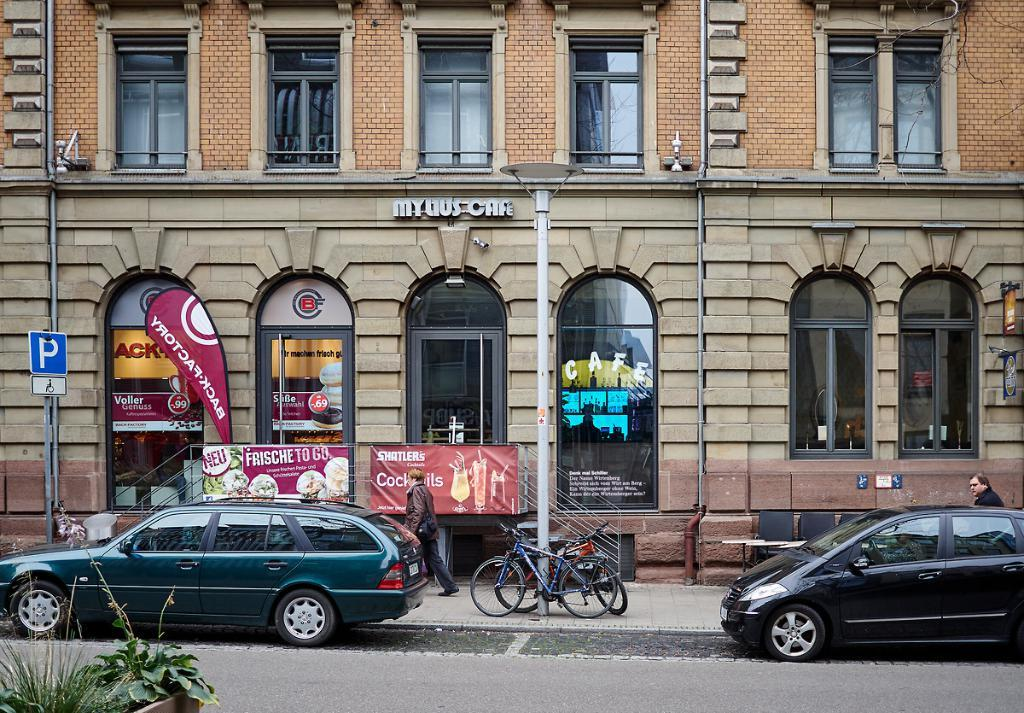How many vehicles can be seen in the image? There are two cars in the image. What other mode of transportation is present in the image? There are some bicycles in the image. Can you describe the person in the image? There is a person walking in the image. What type of structure is visible in the image? There is a building in the image. Where is the goose swimming in the image? There is no goose present in the image. Can you describe the jellyfish floating in the image? There are no jellyfish present in the image. 